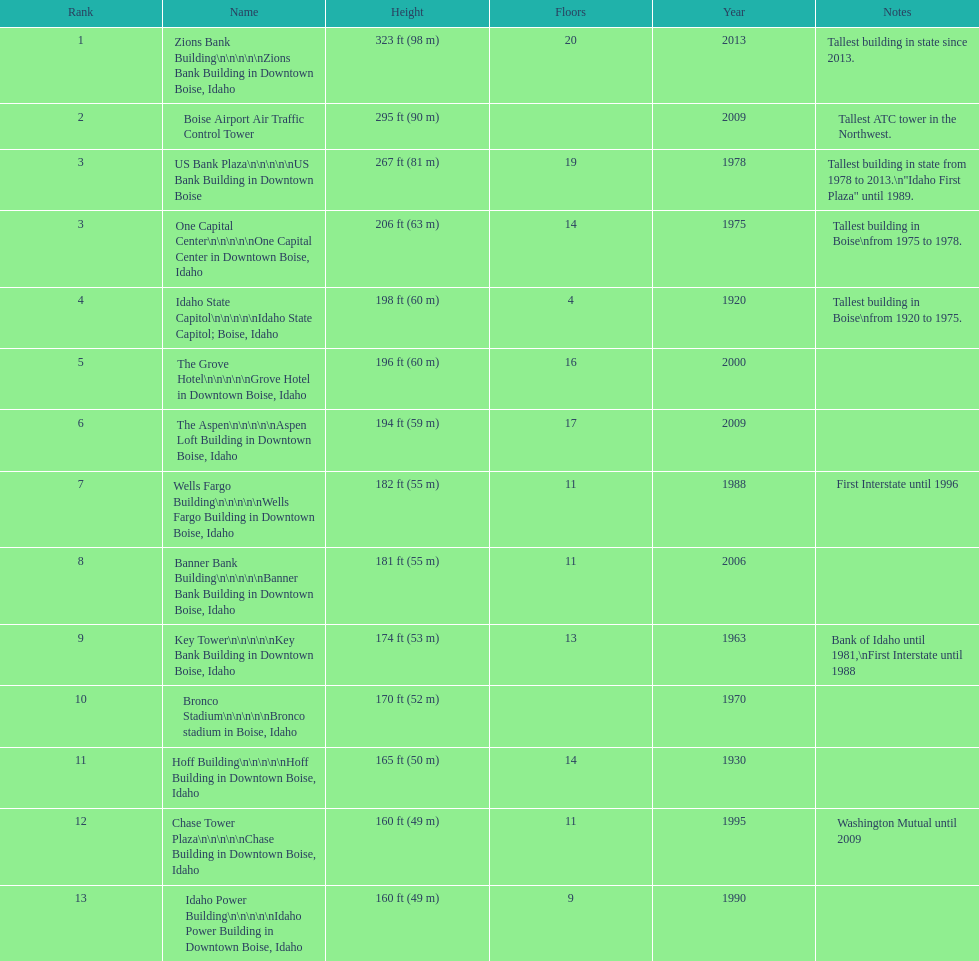What is the tallest building in bosie, idaho? Zions Bank Building Zions Bank Building in Downtown Boise, Idaho. 